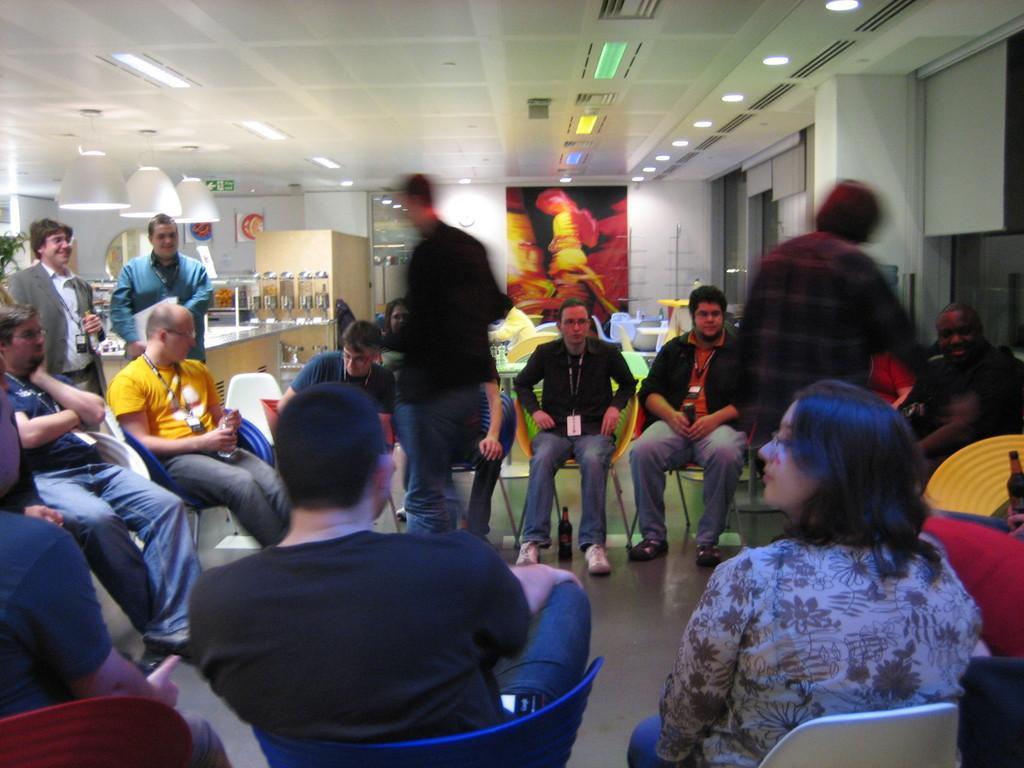How would you summarize this image in a sentence or two? As we can see in the image there are group of people, chairs, tables, lights, white color wall and banner. 